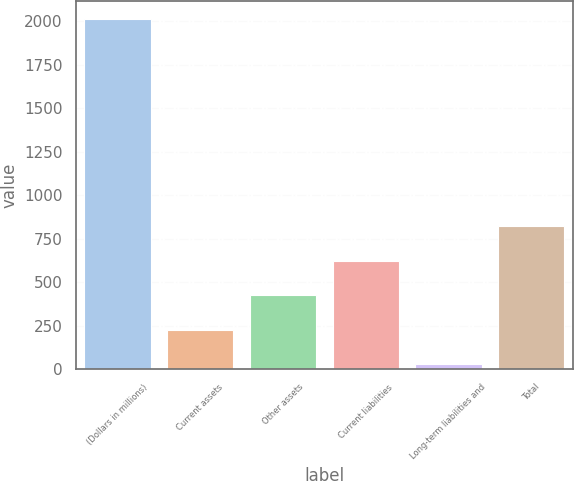<chart> <loc_0><loc_0><loc_500><loc_500><bar_chart><fcel>(Dollars in millions)<fcel>Current assets<fcel>Other assets<fcel>Current liabilities<fcel>Long-term liabilities and<fcel>Total<nl><fcel>2016<fcel>227.7<fcel>426.4<fcel>625.1<fcel>29<fcel>823.8<nl></chart> 